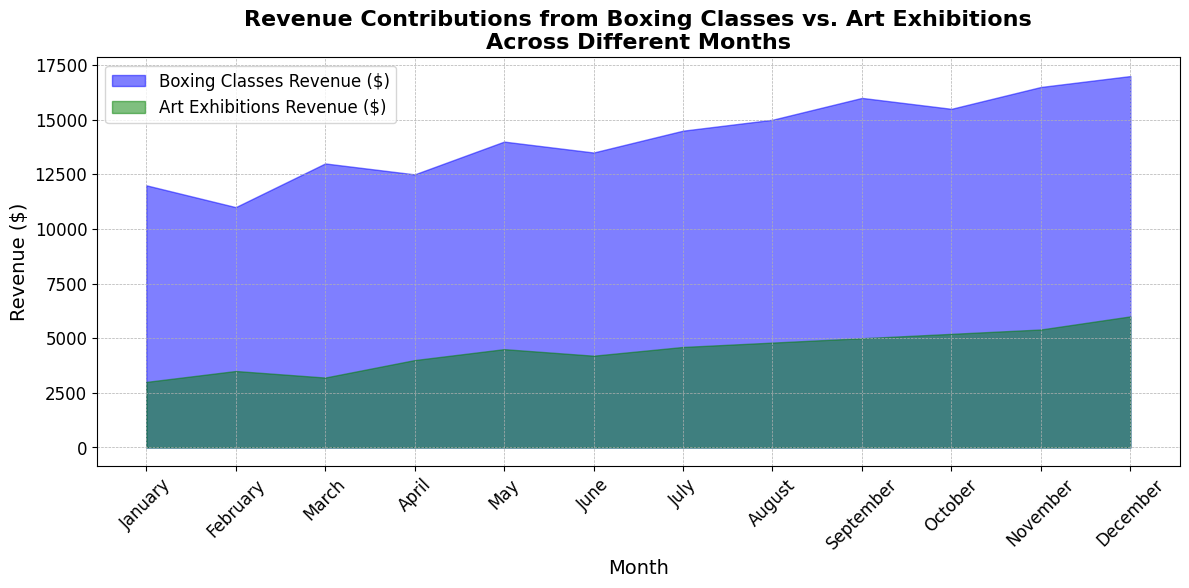Which month had the highest revenue from Boxing Classes? By looking at the blue area corresponding to Boxing Classes Revenue, we can observe that the peak occurs in December.
Answer: December Compare the revenue from Boxing Classes and Art Exhibitions in July. Which one is higher? In July, the height of the blue area (Boxing Classes Revenue) is taller than the green area (Art Exhibitions Revenue), indicating higher revenue.
Answer: Boxing Classes What is the total revenue from both Boxing Classes and Art Exhibitions in November? November's revenue from Boxing Classes is $16,500 and from Art Exhibitions is $5,400. Summing these values: $16,500 + $5,400 = $21,900.
Answer: $21,900 By how much did the revenue from Art Exhibitions increase from February to December? Revenue from Art Exhibitions in February was $3,500, and in December it was $6,000. The increase is $6,000 - $3,500 = $2,500.
Answer: $2,500 Which month had the smallest revenue difference between Boxing Classes and Art Exhibitions? We need to visually compare the gap between the blue and green areas for each month. The smallest visible gap appears in February.
Answer: February In which months did both Boxing Classes and Art Exhibitions experience a revenue increase compared to the previous month? Reviewing the gradual increase in height for both the blue and green areas month-by-month, we find that both revenues increased in April, July, and December compared to their preceding months.
Answer: April, July, December Across the entire year, which revenue stream (Boxing Classes or Art Exhibitions) showed more variability? Visually, the blue area has larger fluctuations in height from month to month compared to the more gradual increase in the green area, suggesting higher variability in Boxing Classes Revenue.
Answer: Boxing Classes Calculate the average monthly revenue for Art Exhibitions over the year. Summing the monthly revenues: $3,000 + $3,500 + $3,200 + $4,000 + $4,500 + $4,200 + $4,600 + $4,800 + $5,000 + $5,200 + $5,400 + $6,000 = $53,400. Dividing by 12 months, the average is $53,400 / 12 ≈ $4,450.
Answer: ≈ $4,450 What is the cumulative revenue from Boxing Classes for the first half of the year (January - June)? Summing Boxing Classes revenues for January to June: $12,000 + $11,000 + $13,000 + $12,500 + $14,000 + $13,500 = $76,000.
Answer: $76,000 Identify one month where Boxing Classes had a noticeable revenue spike compared to the previous month. Between August and September, the blue area increases steeply, indicating a noticeable revenue spike in September.
Answer: September 